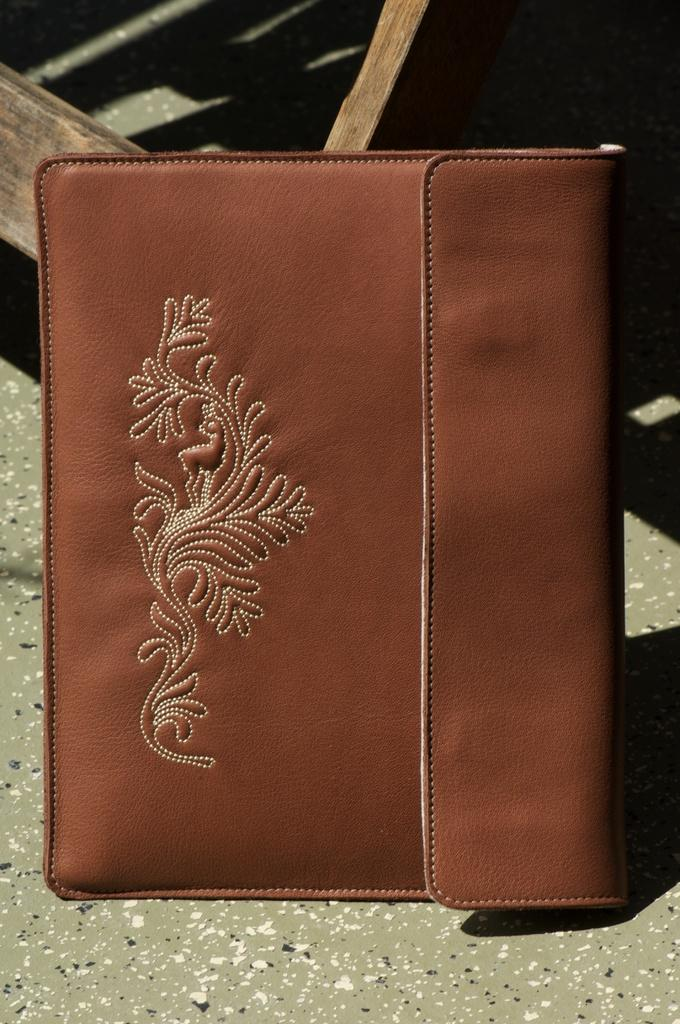What is the main object in the center of the image? There is a wallet in the center of the image. What can be seen at the top of the image? There is a piece of wood at the top of the image. What type of surface is visible in the background of the image? There is a ground visible in the background of the image. How many children are playing with the waves in the background of the image? There are no children or waves present in the image; it only features a wallet and a piece of wood. 